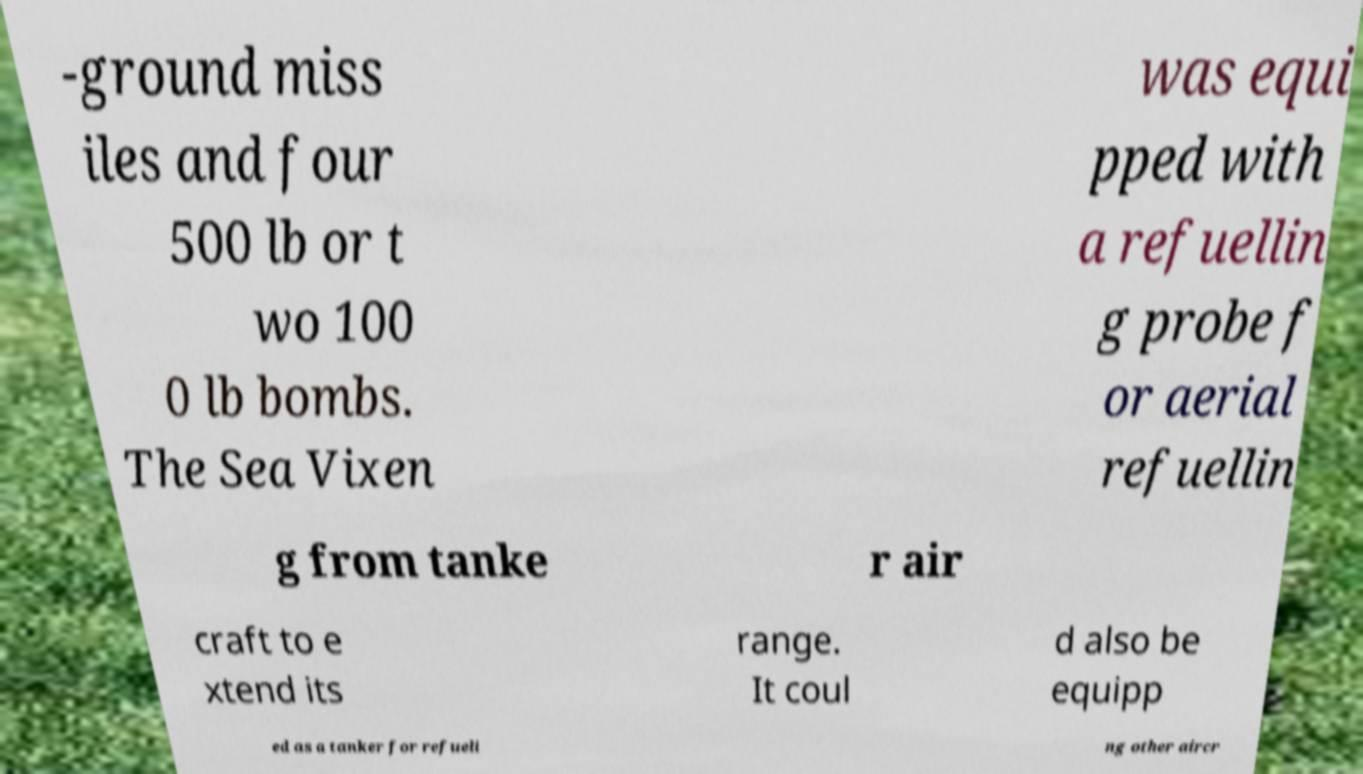Could you assist in decoding the text presented in this image and type it out clearly? -ground miss iles and four 500 lb or t wo 100 0 lb bombs. The Sea Vixen was equi pped with a refuellin g probe f or aerial refuellin g from tanke r air craft to e xtend its range. It coul d also be equipp ed as a tanker for refueli ng other aircr 